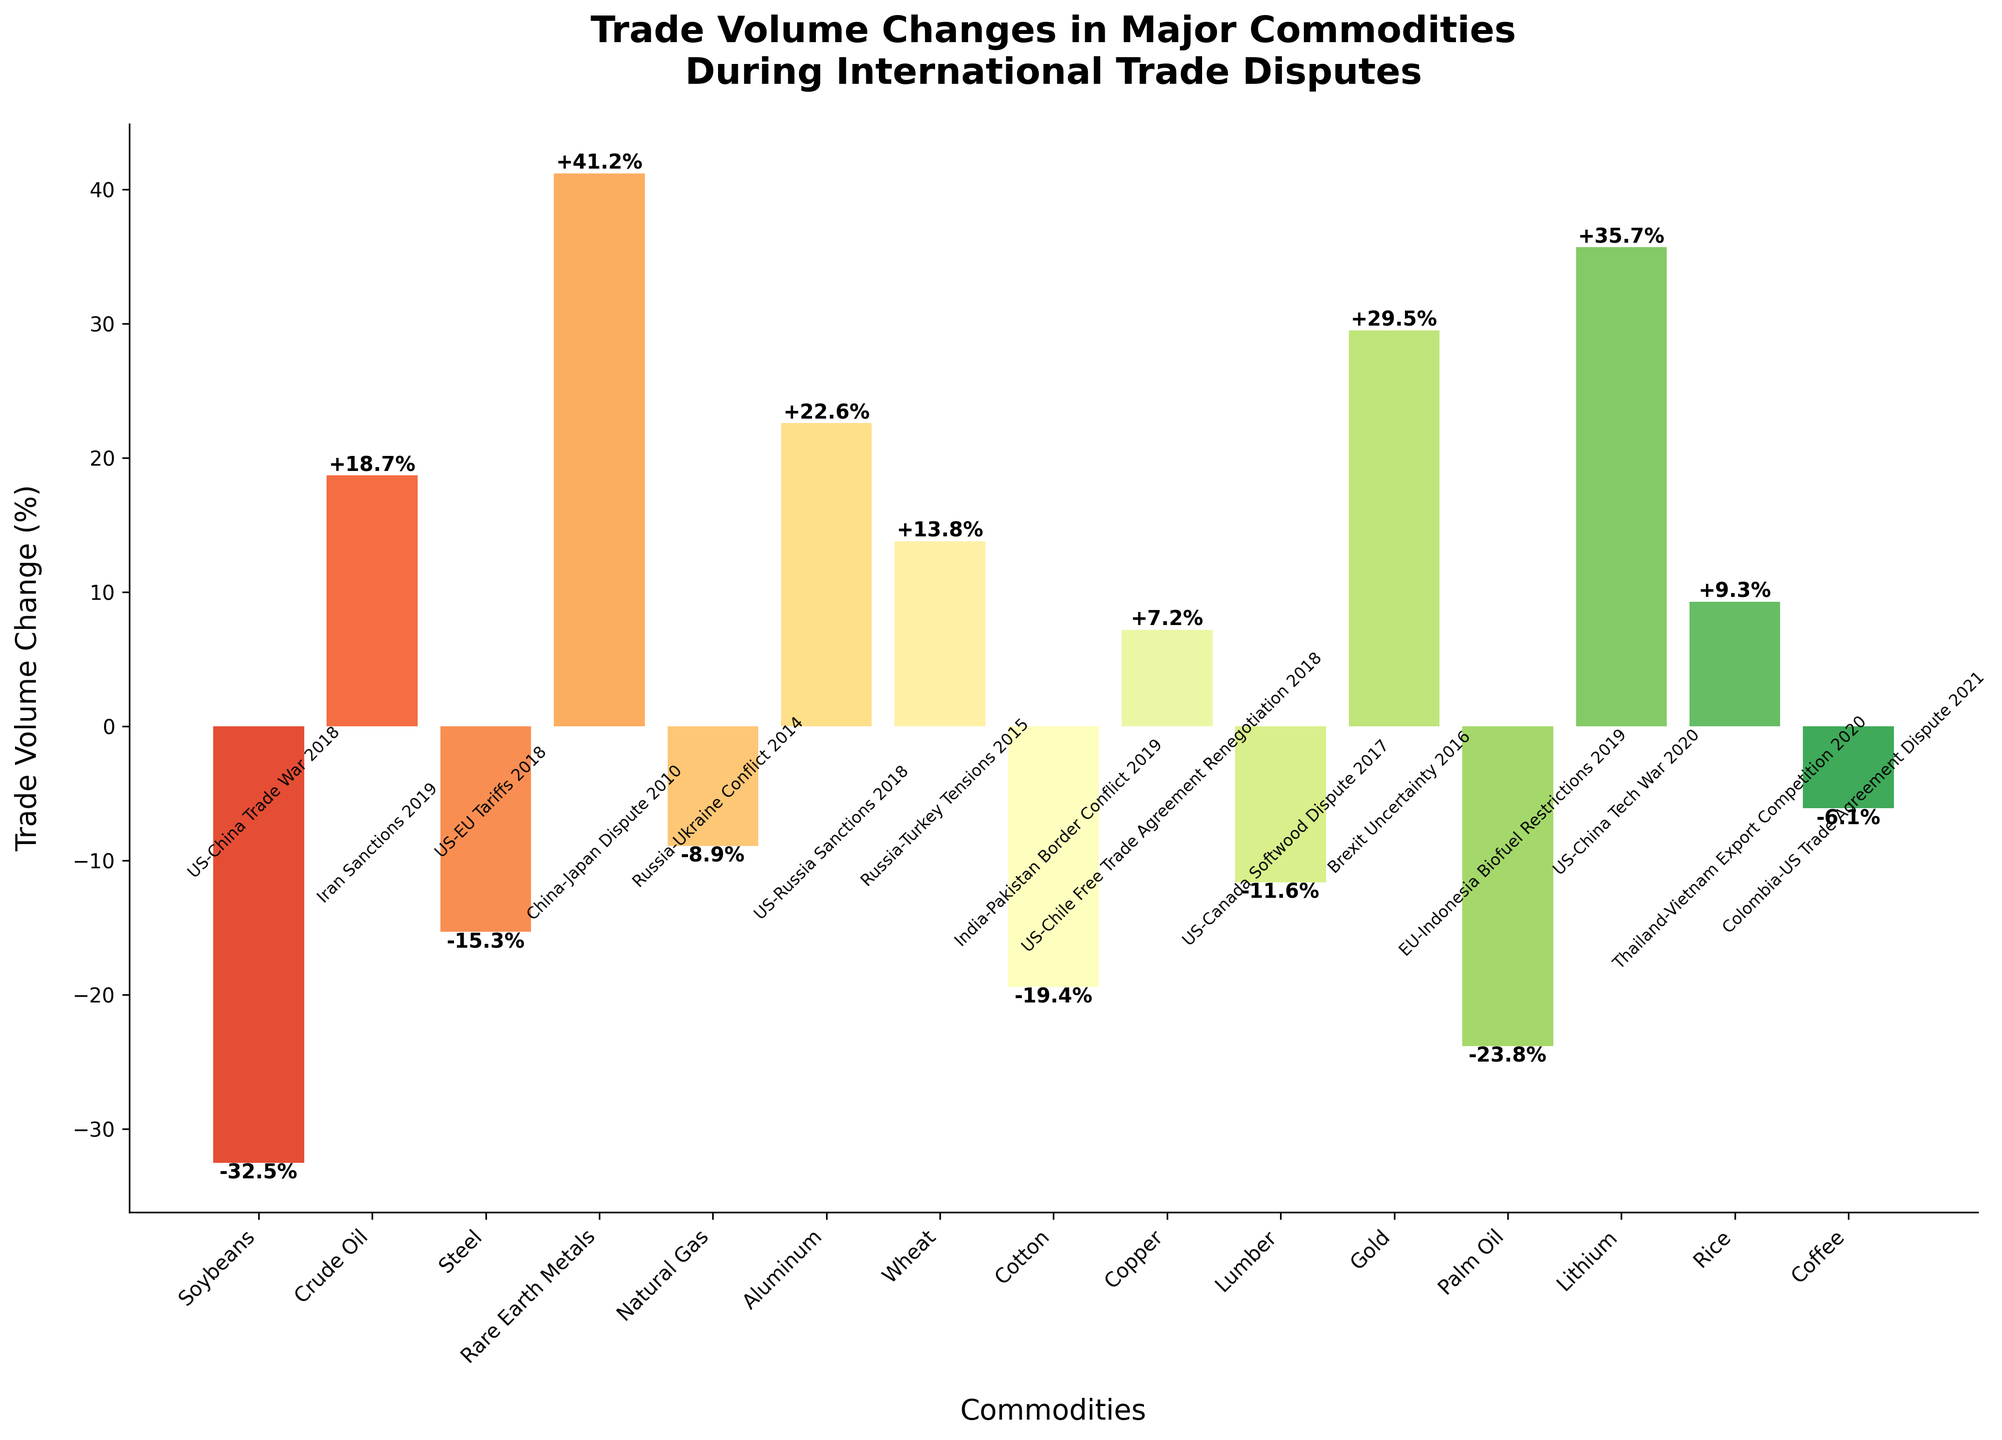What's the largest increase in trade volume, and for which commodity did it occur? First, look for the highest bar in the plot. The bar representing Rare Earth Metals has the highest increase, with a change of +41.2%.
Answer: Rare Earth Metals (+41.2%) Which commodity experienced the largest decrease in trade volume, and by how much? Identify the commodity with the lowest bar below zero. Soybeans have the largest decrease in trade volume at -32.5%.
Answer: Soybeans (-32.5%) Compare the trade volume changes of Wheat and Rice. Which commodity had a higher increase? Locate the bars for Wheat and Rice. Wheat had a trade volume increase of +13.8%, while Rice had a +9.3% increase. Wheat's increase is higher.
Answer: Wheat (+13.8%) Calculate the average trade volume change for commodities that experienced a positive change. Identify commodities with positive bars: Crude Oil (+18.7%), Rare Earth Metals (+41.2%), Aluminum (+22.6%), Wheat (+13.8%), Copper (+7.2%), Gold (+29.5%), Lithium (+35.7%), and Rice (+9.3%). Sum these values and divide by 8. The average is (18.7 + 41.2 + 22.6 + 13.8 + 7.2 + 29.5 + 35.7 + 9.3) / 8 = 22.25%.
Answer: 22.25% Which trade dispute had the most significant impact on decreasing a commodity's trade volume? Look for the longest decreasing bar and note the associated dispute. The Soybeans trade volume decreased the most due to the US-China Trade War 2018.
Answer: US-China Trade War 2018 Of Steel and Aluminum, which commodity had a better trade volume change? Locate the bars for Steel and Aluminum. Steel had a change of -15.3% while Aluminum had a change of +22.6%. Aluminum's change is better as it is positive.
Answer: Aluminum (+22.6%) What is the difference in trade volume change between the commodity with the highest increase and the highest decrease? Find the highest increase (+41.2% for Rare Earth Metals) and the highest decrease (-32.5% for Soybeans). Calculate the difference: 41.2 - (-32.5) = 73.7%.
Answer: 73.7% Compare the trade volume change of commodities affected by disputes in 2018. Which commodity had the highest increase? Identify commodities affected in 2018: Soybeans (-32.5%), Steel (-15.3%), Aluminum (+22.6%), and Copper (+7.2%). Among them, Aluminum had the highest increase at +22.6%.
Answer: Aluminum (+22.6%) What is the combined trade volume change of commodities affected by sanctions? Identify commodities affected by sanctions; Crude Oil (+18.7%), Aluminum (+22.6%). Sum these values to find the combined change: 18.7 + 22.6 = 41.3%.
Answer: 41.3% 